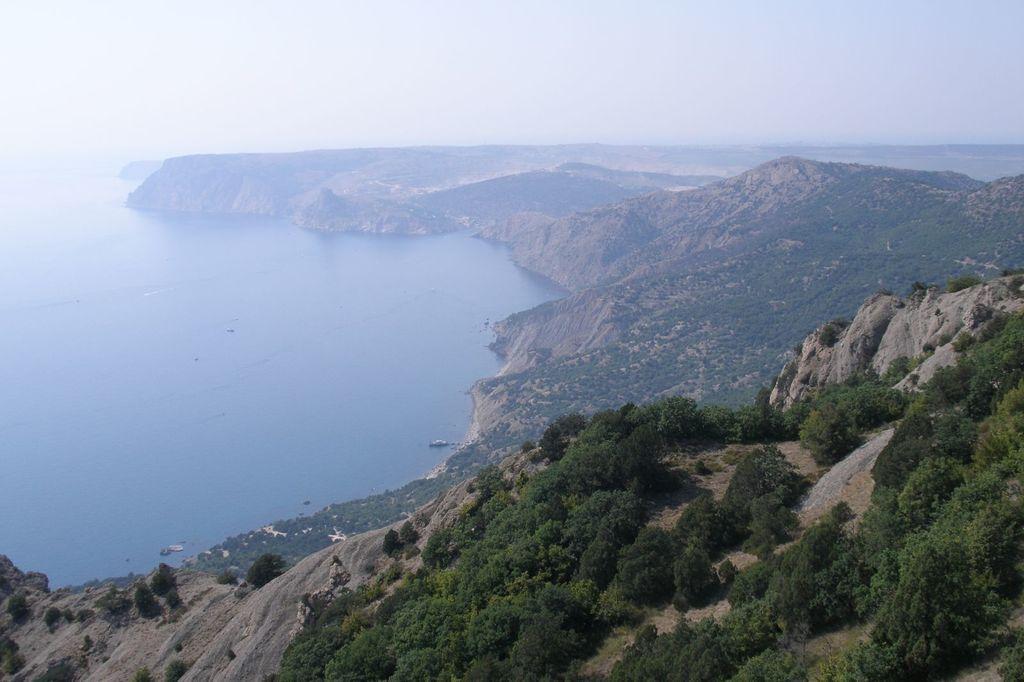Can you describe this image briefly? In this picture I can observe a river on the left side. There are some hills and trees in this picture. In the background there is sky. 